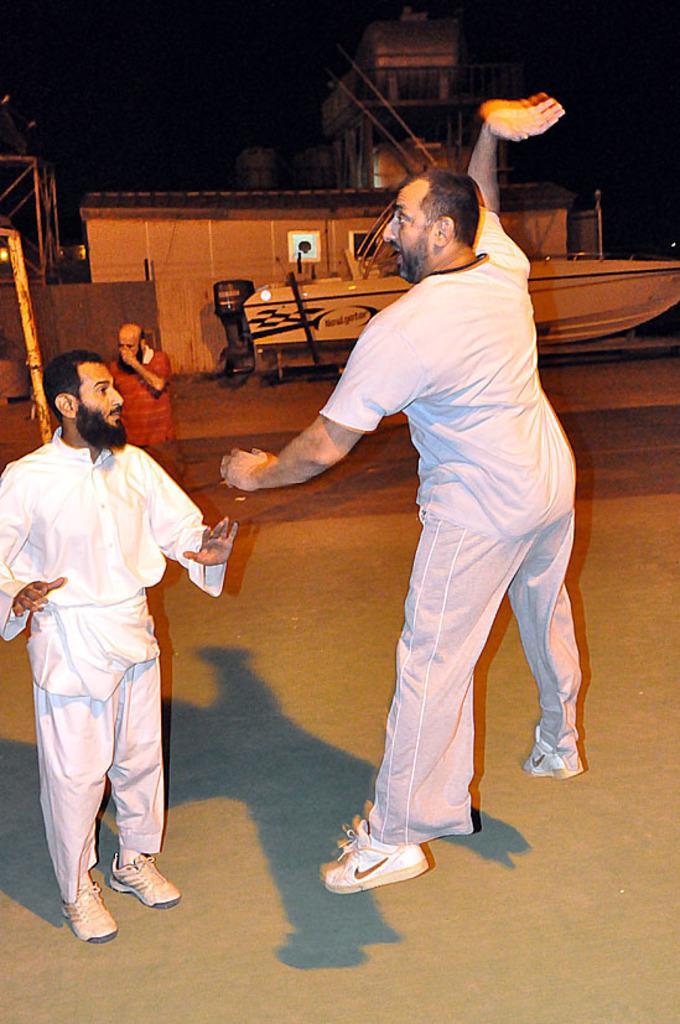Describe this image in one or two sentences. In this picture we can see group of people, in the background we can find few metal rods, boat and few buildings. 